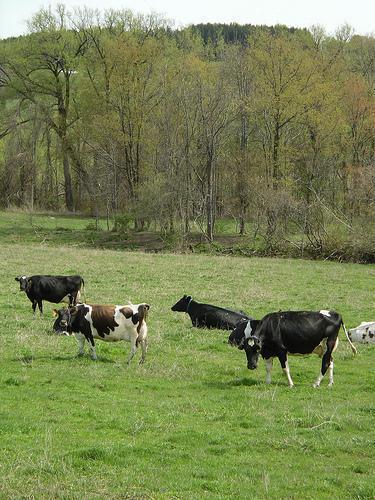How many cows are there?
Give a very brief answer. 6. 